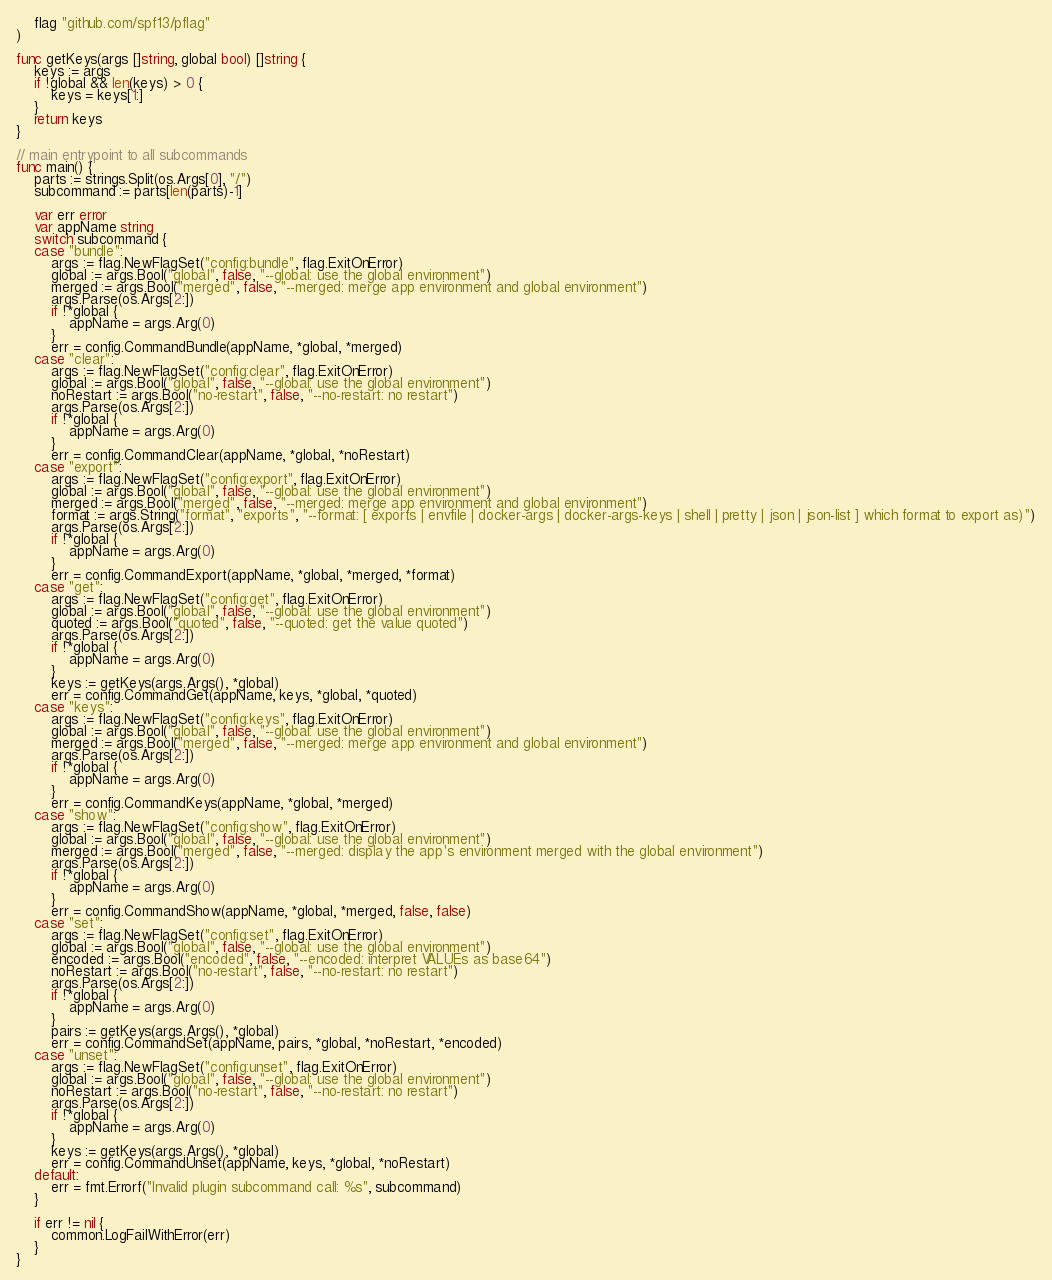Convert code to text. <code><loc_0><loc_0><loc_500><loc_500><_Go_>
	flag "github.com/spf13/pflag"
)

func getKeys(args []string, global bool) []string {
	keys := args
	if !global && len(keys) > 0 {
		keys = keys[1:]
	}
	return keys
}

// main entrypoint to all subcommands
func main() {
	parts := strings.Split(os.Args[0], "/")
	subcommand := parts[len(parts)-1]

	var err error
	var appName string
	switch subcommand {
	case "bundle":
		args := flag.NewFlagSet("config:bundle", flag.ExitOnError)
		global := args.Bool("global", false, "--global: use the global environment")
		merged := args.Bool("merged", false, "--merged: merge app environment and global environment")
		args.Parse(os.Args[2:])
		if !*global {
			appName = args.Arg(0)
		}
		err = config.CommandBundle(appName, *global, *merged)
	case "clear":
		args := flag.NewFlagSet("config:clear", flag.ExitOnError)
		global := args.Bool("global", false, "--global: use the global environment")
		noRestart := args.Bool("no-restart", false, "--no-restart: no restart")
		args.Parse(os.Args[2:])
		if !*global {
			appName = args.Arg(0)
		}
		err = config.CommandClear(appName, *global, *noRestart)
	case "export":
		args := flag.NewFlagSet("config:export", flag.ExitOnError)
		global := args.Bool("global", false, "--global: use the global environment")
		merged := args.Bool("merged", false, "--merged: merge app environment and global environment")
		format := args.String("format", "exports", "--format: [ exports | envfile | docker-args | docker-args-keys | shell | pretty | json | json-list ] which format to export as)")
		args.Parse(os.Args[2:])
		if !*global {
			appName = args.Arg(0)
		}
		err = config.CommandExport(appName, *global, *merged, *format)
	case "get":
		args := flag.NewFlagSet("config:get", flag.ExitOnError)
		global := args.Bool("global", false, "--global: use the global environment")
		quoted := args.Bool("quoted", false, "--quoted: get the value quoted")
		args.Parse(os.Args[2:])
		if !*global {
			appName = args.Arg(0)
		}
		keys := getKeys(args.Args(), *global)
		err = config.CommandGet(appName, keys, *global, *quoted)
	case "keys":
		args := flag.NewFlagSet("config:keys", flag.ExitOnError)
		global := args.Bool("global", false, "--global: use the global environment")
		merged := args.Bool("merged", false, "--merged: merge app environment and global environment")
		args.Parse(os.Args[2:])
		if !*global {
			appName = args.Arg(0)
		}
		err = config.CommandKeys(appName, *global, *merged)
	case "show":
		args := flag.NewFlagSet("config:show", flag.ExitOnError)
		global := args.Bool("global", false, "--global: use the global environment")
		merged := args.Bool("merged", false, "--merged: display the app's environment merged with the global environment")
		args.Parse(os.Args[2:])
		if !*global {
			appName = args.Arg(0)
		}
		err = config.CommandShow(appName, *global, *merged, false, false)
	case "set":
		args := flag.NewFlagSet("config:set", flag.ExitOnError)
		global := args.Bool("global", false, "--global: use the global environment")
		encoded := args.Bool("encoded", false, "--encoded: interpret VALUEs as base64")
		noRestart := args.Bool("no-restart", false, "--no-restart: no restart")
		args.Parse(os.Args[2:])
		if !*global {
			appName = args.Arg(0)
		}
		pairs := getKeys(args.Args(), *global)
		err = config.CommandSet(appName, pairs, *global, *noRestart, *encoded)
	case "unset":
		args := flag.NewFlagSet("config:unset", flag.ExitOnError)
		global := args.Bool("global", false, "--global: use the global environment")
		noRestart := args.Bool("no-restart", false, "--no-restart: no restart")
		args.Parse(os.Args[2:])
		if !*global {
			appName = args.Arg(0)
		}
		keys := getKeys(args.Args(), *global)
		err = config.CommandUnset(appName, keys, *global, *noRestart)
	default:
		err = fmt.Errorf("Invalid plugin subcommand call: %s", subcommand)
	}

	if err != nil {
		common.LogFailWithError(err)
	}
}
</code> 